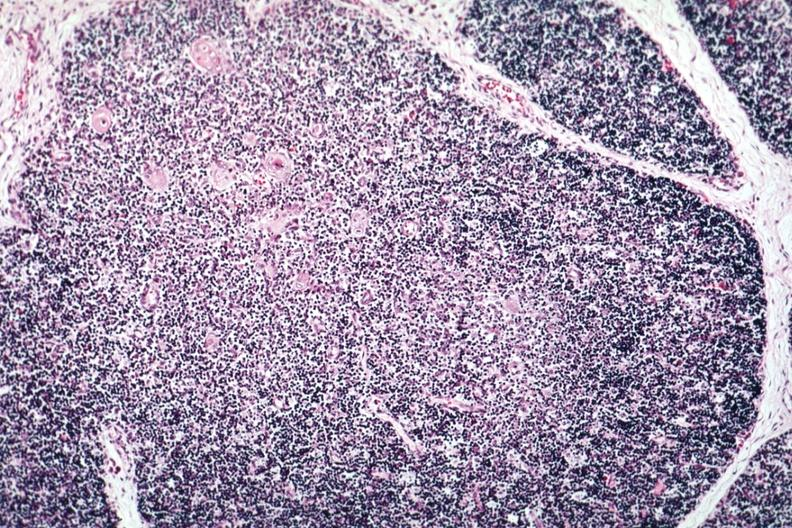what is present?
Answer the question using a single word or phrase. Normal immature infant 